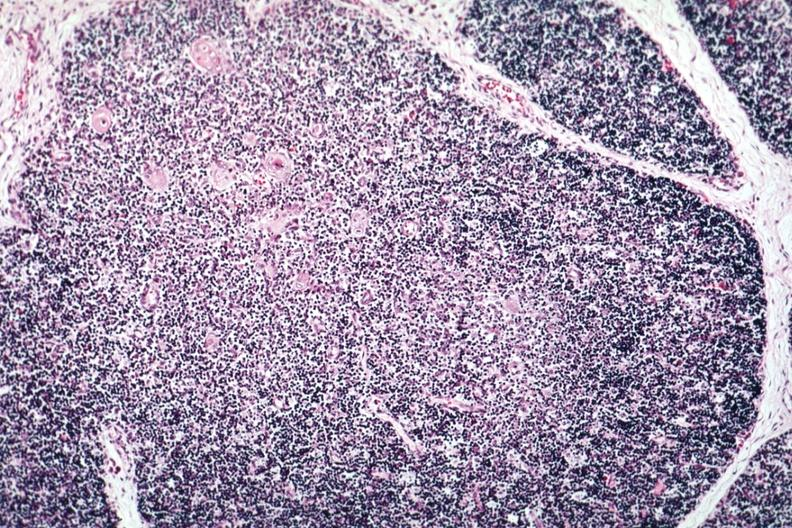what is present?
Answer the question using a single word or phrase. Normal immature infant 